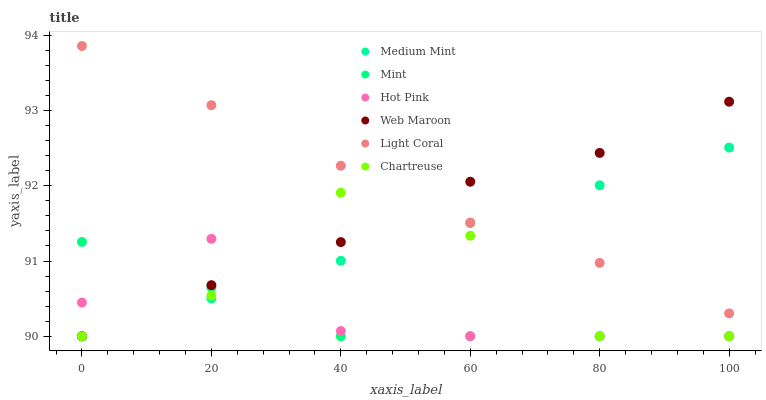Does Mint have the minimum area under the curve?
Answer yes or no. Yes. Does Light Coral have the maximum area under the curve?
Answer yes or no. Yes. Does Hot Pink have the minimum area under the curve?
Answer yes or no. No. Does Hot Pink have the maximum area under the curve?
Answer yes or no. No. Is Medium Mint the smoothest?
Answer yes or no. Yes. Is Chartreuse the roughest?
Answer yes or no. Yes. Is Hot Pink the smoothest?
Answer yes or no. No. Is Hot Pink the roughest?
Answer yes or no. No. Does Medium Mint have the lowest value?
Answer yes or no. Yes. Does Light Coral have the lowest value?
Answer yes or no. No. Does Light Coral have the highest value?
Answer yes or no. Yes. Does Hot Pink have the highest value?
Answer yes or no. No. Is Hot Pink less than Light Coral?
Answer yes or no. Yes. Is Light Coral greater than Hot Pink?
Answer yes or no. Yes. Does Light Coral intersect Medium Mint?
Answer yes or no. Yes. Is Light Coral less than Medium Mint?
Answer yes or no. No. Is Light Coral greater than Medium Mint?
Answer yes or no. No. Does Hot Pink intersect Light Coral?
Answer yes or no. No. 